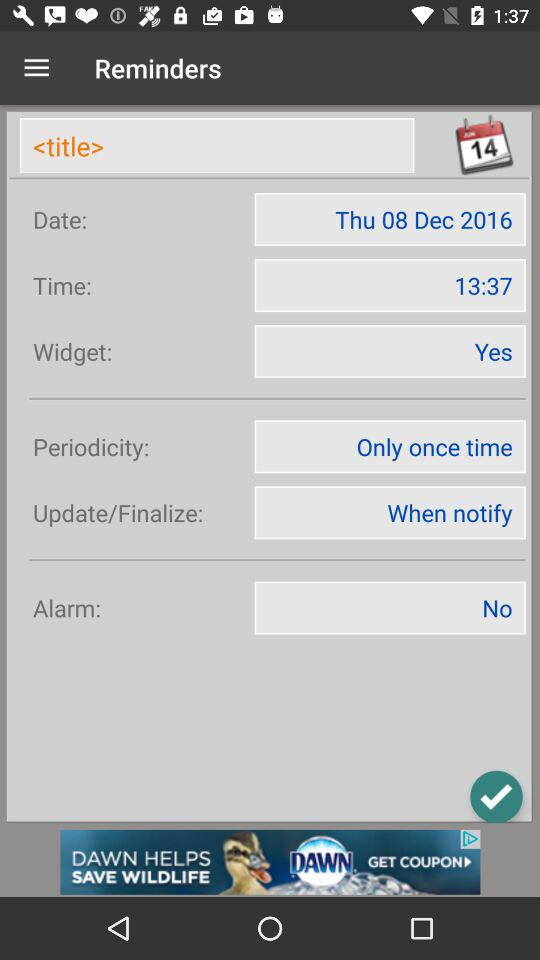What is the given date? The given date is Thursday, December 8, 2016. 